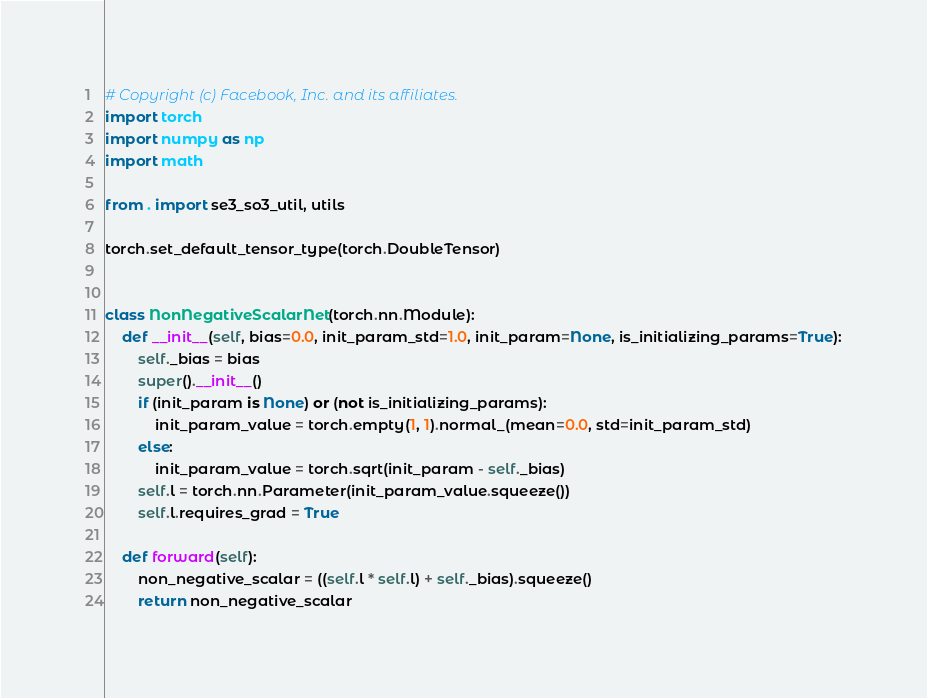<code> <loc_0><loc_0><loc_500><loc_500><_Python_># Copyright (c) Facebook, Inc. and its affiliates.
import torch
import numpy as np
import math

from . import se3_so3_util, utils

torch.set_default_tensor_type(torch.DoubleTensor)


class NonNegativeScalarNet(torch.nn.Module):
    def __init__(self, bias=0.0, init_param_std=1.0, init_param=None, is_initializing_params=True):
        self._bias = bias
        super().__init__()
        if (init_param is None) or (not is_initializing_params):
            init_param_value = torch.empty(1, 1).normal_(mean=0.0, std=init_param_std)
        else:
            init_param_value = torch.sqrt(init_param - self._bias)
        self.l = torch.nn.Parameter(init_param_value.squeeze())
        self.l.requires_grad = True

    def forward(self):
        non_negative_scalar = ((self.l * self.l) + self._bias).squeeze()
        return non_negative_scalar

</code> 